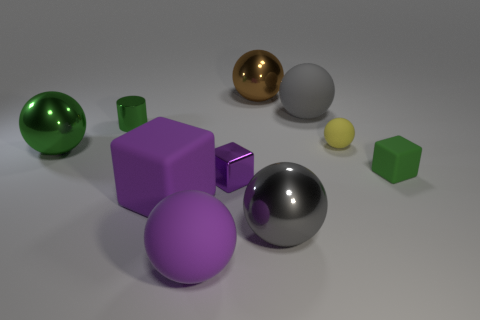Subtract all green spheres. How many spheres are left? 5 Subtract all small spheres. How many spheres are left? 5 Subtract all purple balls. Subtract all purple blocks. How many balls are left? 5 Subtract all cylinders. How many objects are left? 9 Add 2 big red objects. How many big red objects exist? 2 Subtract 0 brown cylinders. How many objects are left? 10 Subtract all yellow things. Subtract all tiny rubber balls. How many objects are left? 8 Add 6 purple metal blocks. How many purple metal blocks are left? 7 